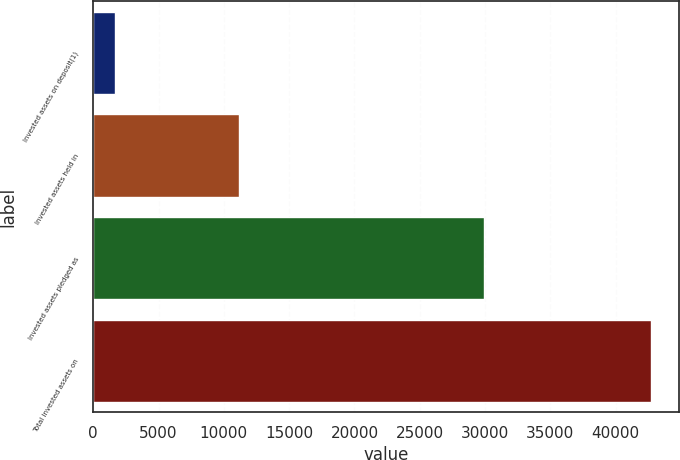<chart> <loc_0><loc_0><loc_500><loc_500><bar_chart><fcel>Invested assets on deposit(1)<fcel>Invested assets held in<fcel>Invested assets pledged as<fcel>Total invested assets on<nl><fcel>1660<fcel>11135<fcel>29899<fcel>42694<nl></chart> 